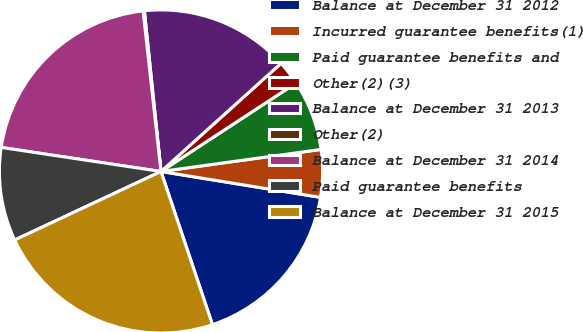Convert chart. <chart><loc_0><loc_0><loc_500><loc_500><pie_chart><fcel>Balance at December 31 2012<fcel>Incurred guarantee benefits(1)<fcel>Paid guarantee benefits and<fcel>Other(2)(3)<fcel>Balance at December 31 2013<fcel>Other(2)<fcel>Balance at December 31 2014<fcel>Paid guarantee benefits<fcel>Balance at December 31 2015<nl><fcel>17.28%<fcel>4.74%<fcel>7.05%<fcel>2.44%<fcel>14.97%<fcel>0.13%<fcel>20.85%<fcel>9.35%<fcel>23.19%<nl></chart> 